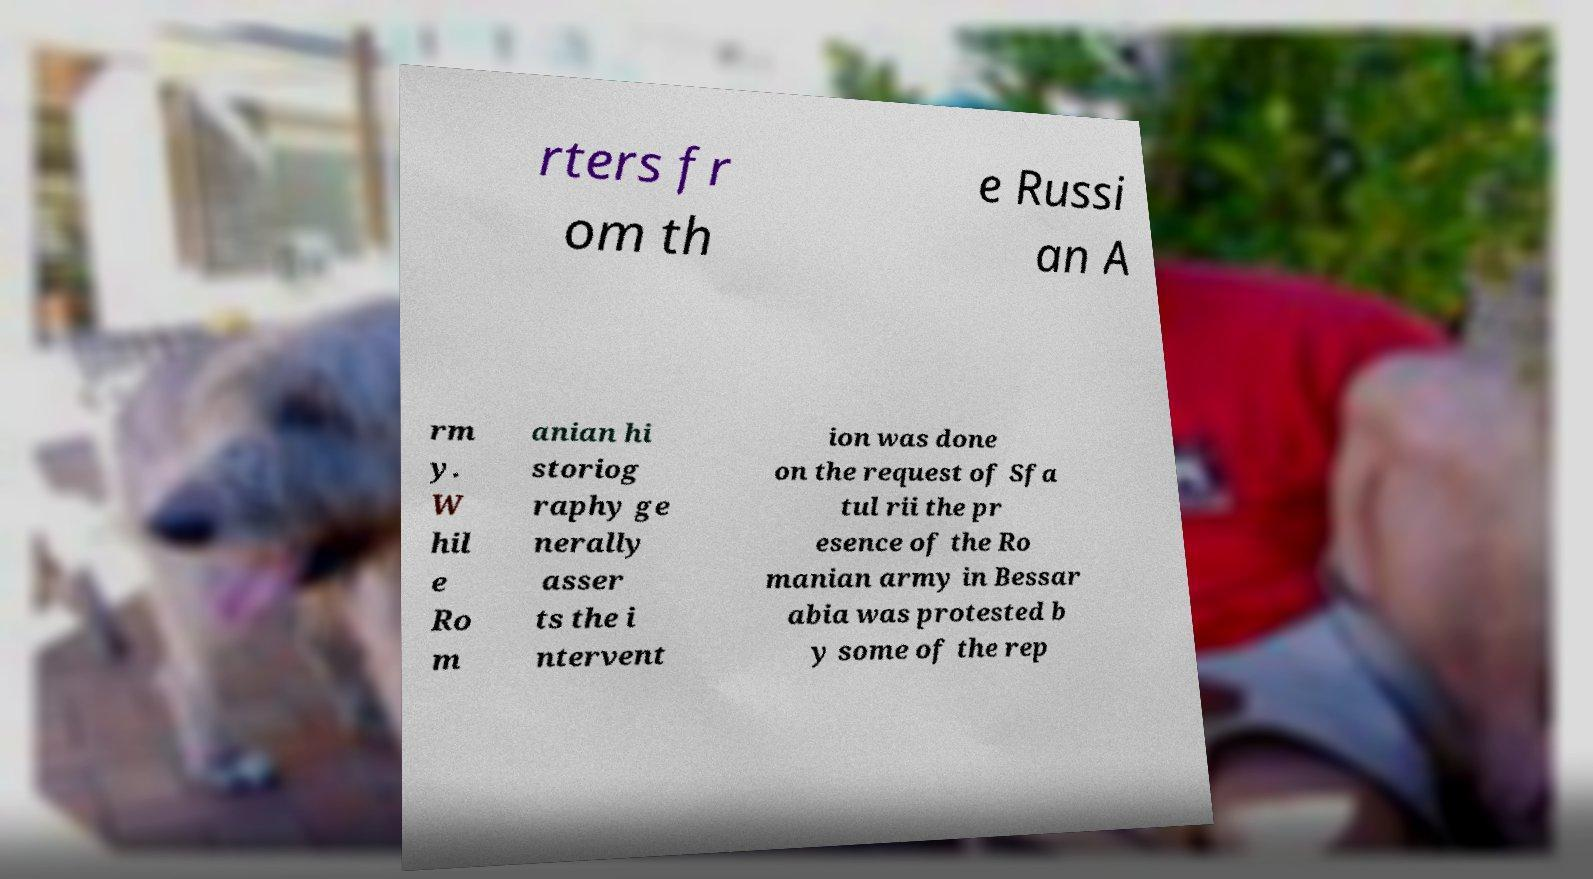Can you accurately transcribe the text from the provided image for me? rters fr om th e Russi an A rm y. W hil e Ro m anian hi storiog raphy ge nerally asser ts the i ntervent ion was done on the request of Sfa tul rii the pr esence of the Ro manian army in Bessar abia was protested b y some of the rep 